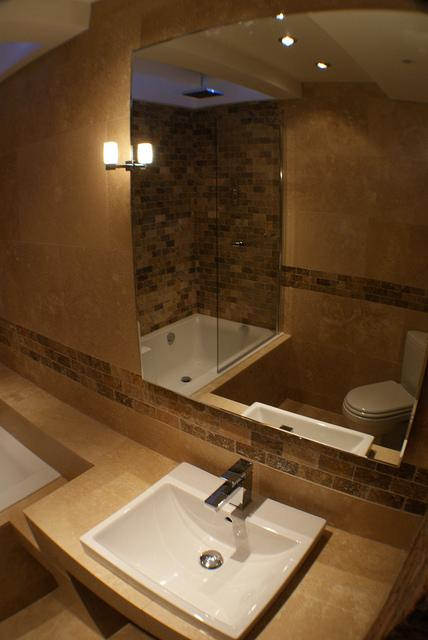Why is there no shower curtain? glass door 